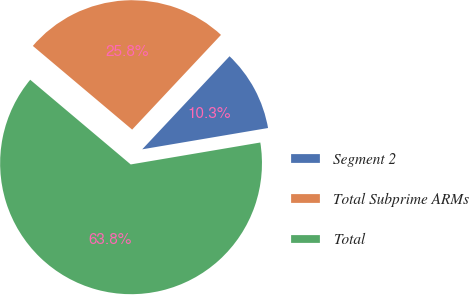Convert chart to OTSL. <chart><loc_0><loc_0><loc_500><loc_500><pie_chart><fcel>Segment 2<fcel>Total Subprime ARMs<fcel>Total<nl><fcel>10.34%<fcel>25.85%<fcel>63.82%<nl></chart> 